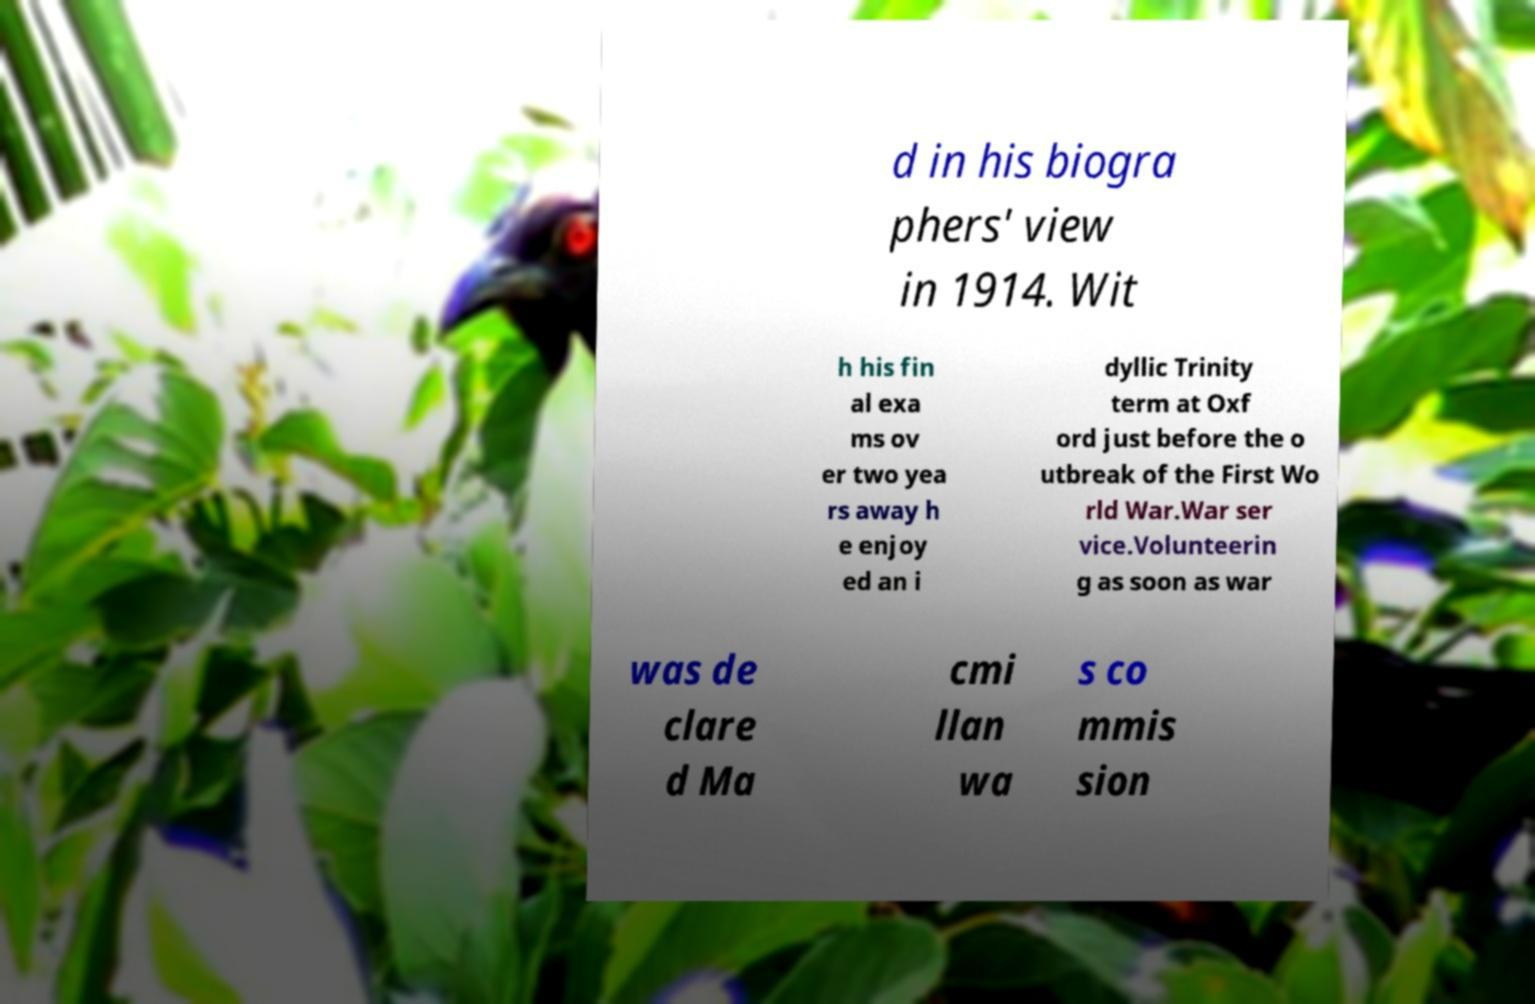Can you read and provide the text displayed in the image?This photo seems to have some interesting text. Can you extract and type it out for me? d in his biogra phers' view in 1914. Wit h his fin al exa ms ov er two yea rs away h e enjoy ed an i dyllic Trinity term at Oxf ord just before the o utbreak of the First Wo rld War.War ser vice.Volunteerin g as soon as war was de clare d Ma cmi llan wa s co mmis sion 